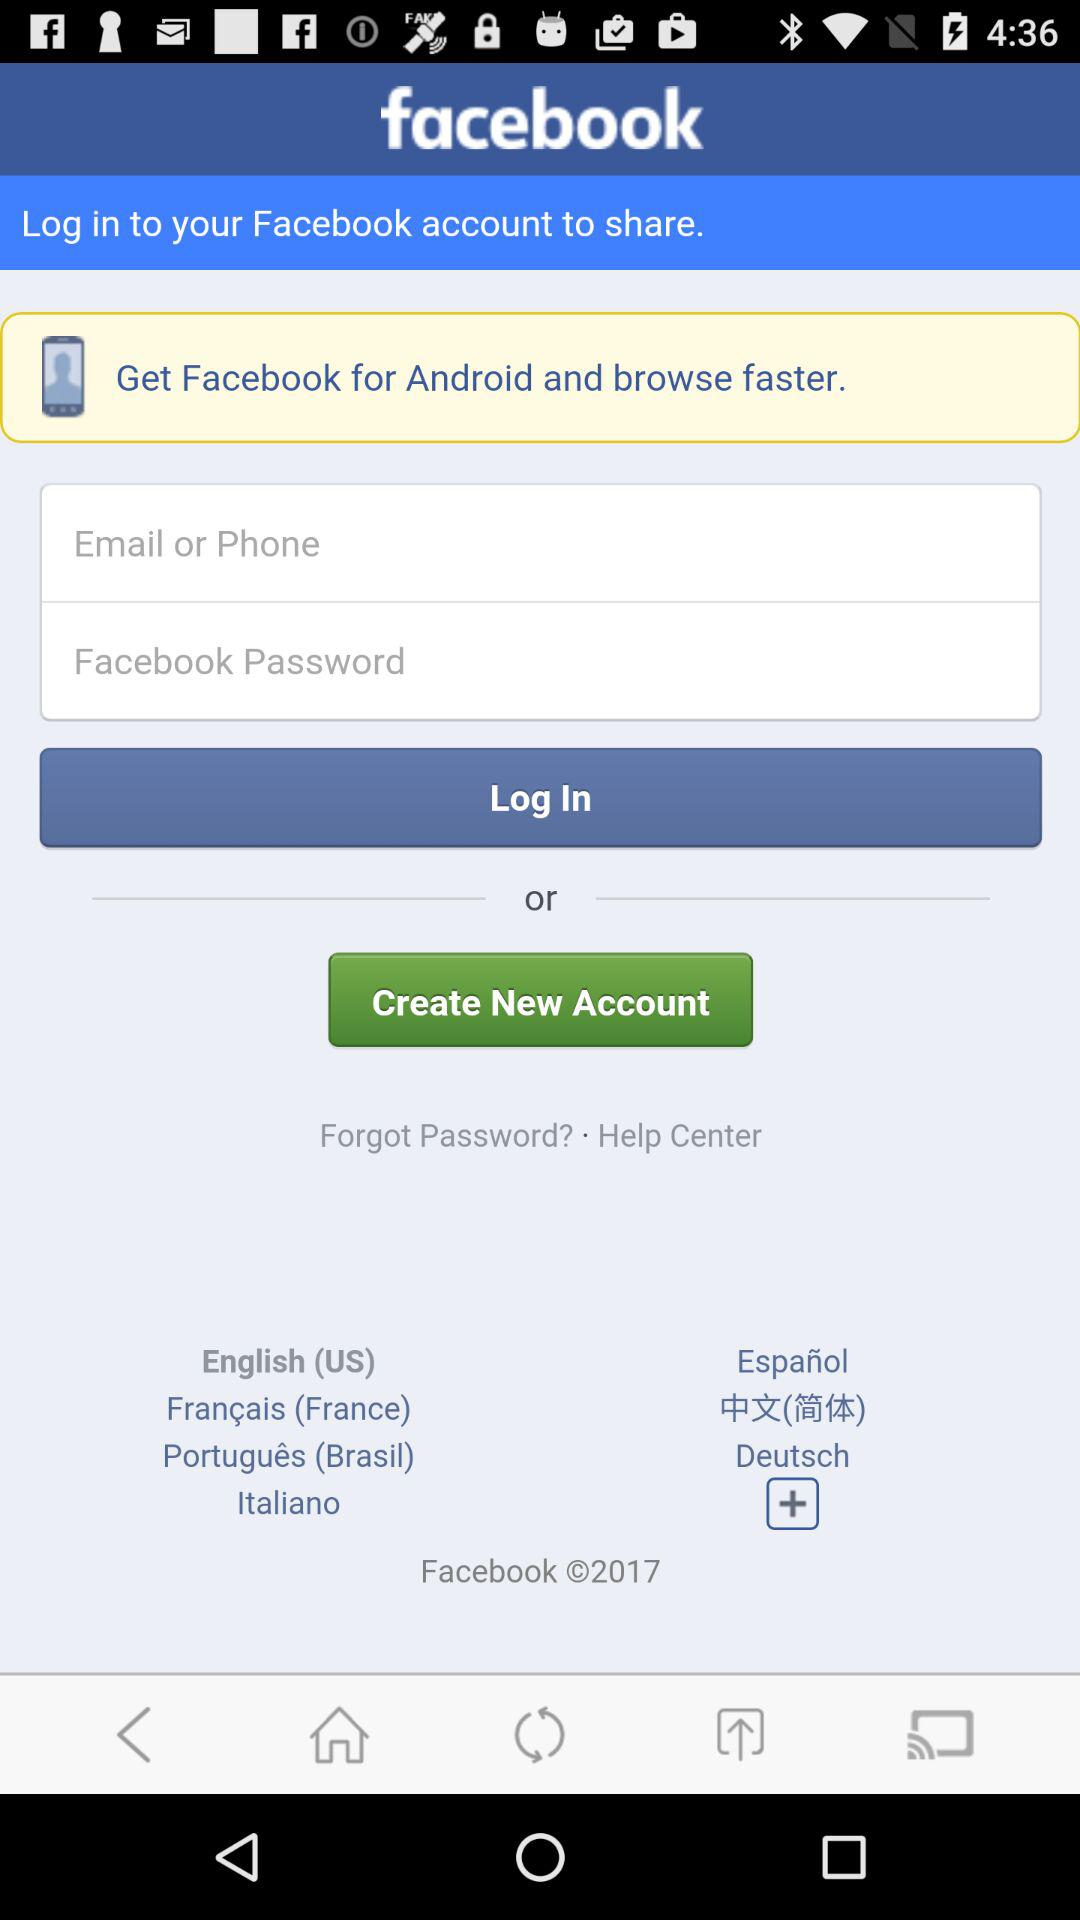What is the year of copyright of the application? The year of copyright of the application is 2017. 